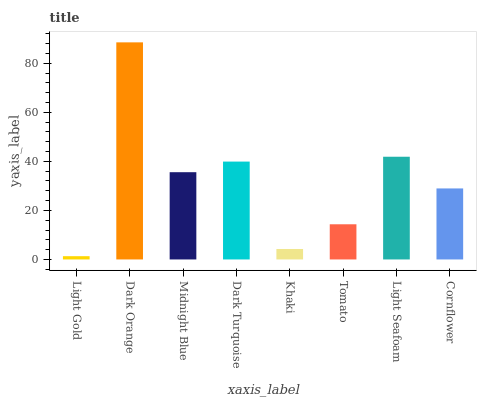Is Light Gold the minimum?
Answer yes or no. Yes. Is Dark Orange the maximum?
Answer yes or no. Yes. Is Midnight Blue the minimum?
Answer yes or no. No. Is Midnight Blue the maximum?
Answer yes or no. No. Is Dark Orange greater than Midnight Blue?
Answer yes or no. Yes. Is Midnight Blue less than Dark Orange?
Answer yes or no. Yes. Is Midnight Blue greater than Dark Orange?
Answer yes or no. No. Is Dark Orange less than Midnight Blue?
Answer yes or no. No. Is Midnight Blue the high median?
Answer yes or no. Yes. Is Cornflower the low median?
Answer yes or no. Yes. Is Light Gold the high median?
Answer yes or no. No. Is Dark Orange the low median?
Answer yes or no. No. 